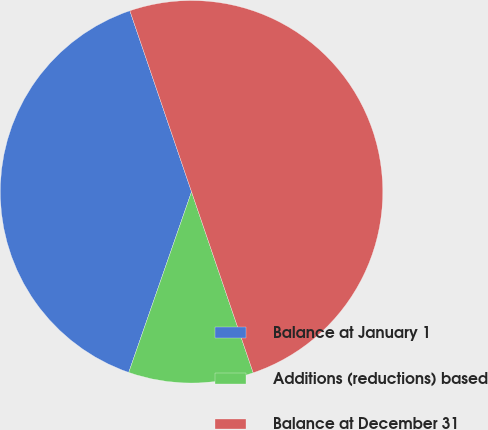Convert chart. <chart><loc_0><loc_0><loc_500><loc_500><pie_chart><fcel>Balance at January 1<fcel>Additions (reductions) based<fcel>Balance at December 31<nl><fcel>39.45%<fcel>10.55%<fcel>50.0%<nl></chart> 